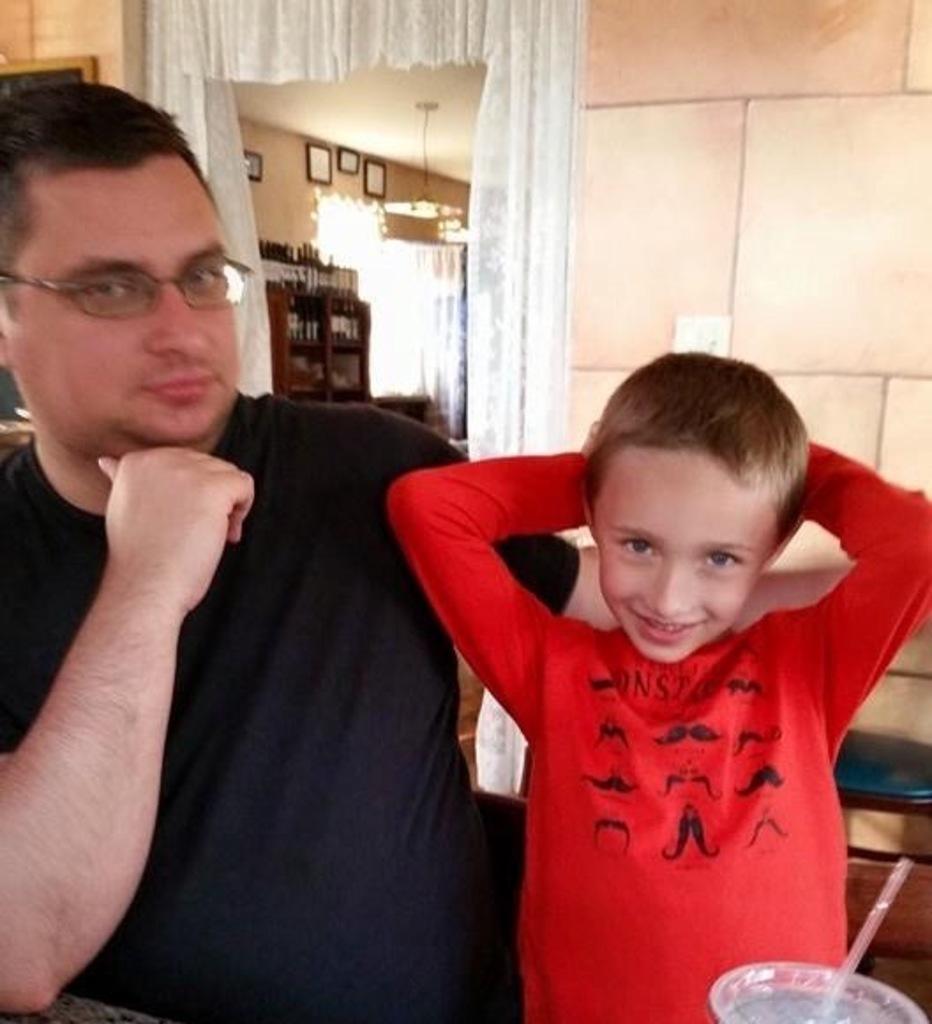Please provide a concise description of this image. In this image we can see a man and a kid standing at the table. On the table we can see glass and straw. In the background we can see door, curtain, wall, photo frames and beverage bottle arranged in shelves. 